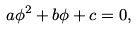<formula> <loc_0><loc_0><loc_500><loc_500>a \phi ^ { 2 } + b \phi + c = 0 ,</formula> 